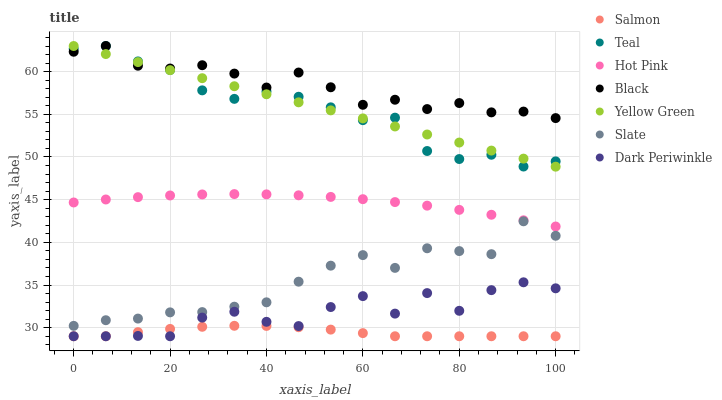Does Salmon have the minimum area under the curve?
Answer yes or no. Yes. Does Black have the maximum area under the curve?
Answer yes or no. Yes. Does Slate have the minimum area under the curve?
Answer yes or no. No. Does Slate have the maximum area under the curve?
Answer yes or no. No. Is Yellow Green the smoothest?
Answer yes or no. Yes. Is Dark Periwinkle the roughest?
Answer yes or no. Yes. Is Slate the smoothest?
Answer yes or no. No. Is Slate the roughest?
Answer yes or no. No. Does Salmon have the lowest value?
Answer yes or no. Yes. Does Slate have the lowest value?
Answer yes or no. No. Does Teal have the highest value?
Answer yes or no. Yes. Does Slate have the highest value?
Answer yes or no. No. Is Dark Periwinkle less than Teal?
Answer yes or no. Yes. Is Teal greater than Salmon?
Answer yes or no. Yes. Does Yellow Green intersect Black?
Answer yes or no. Yes. Is Yellow Green less than Black?
Answer yes or no. No. Is Yellow Green greater than Black?
Answer yes or no. No. Does Dark Periwinkle intersect Teal?
Answer yes or no. No. 